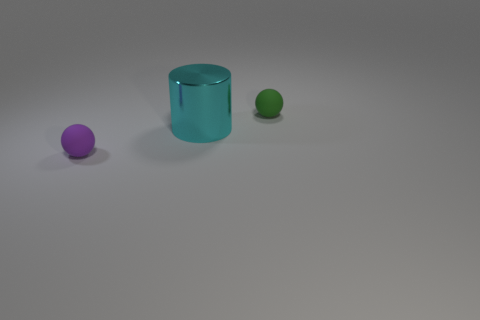What materials do the objects in the image appear to be made of? The small balls appear to be made of rubber due to their matte texture and slight light reflection, while the cylinder seems to be metallic, given its shiny surface and reflective properties. 